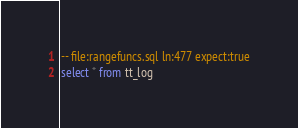<code> <loc_0><loc_0><loc_500><loc_500><_SQL_>-- file:rangefuncs.sql ln:477 expect:true
select * from tt_log
</code> 